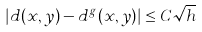<formula> <loc_0><loc_0><loc_500><loc_500>| d ( x , y ) - d ^ { g } ( x , y ) | \leq C \sqrt { h }</formula> 